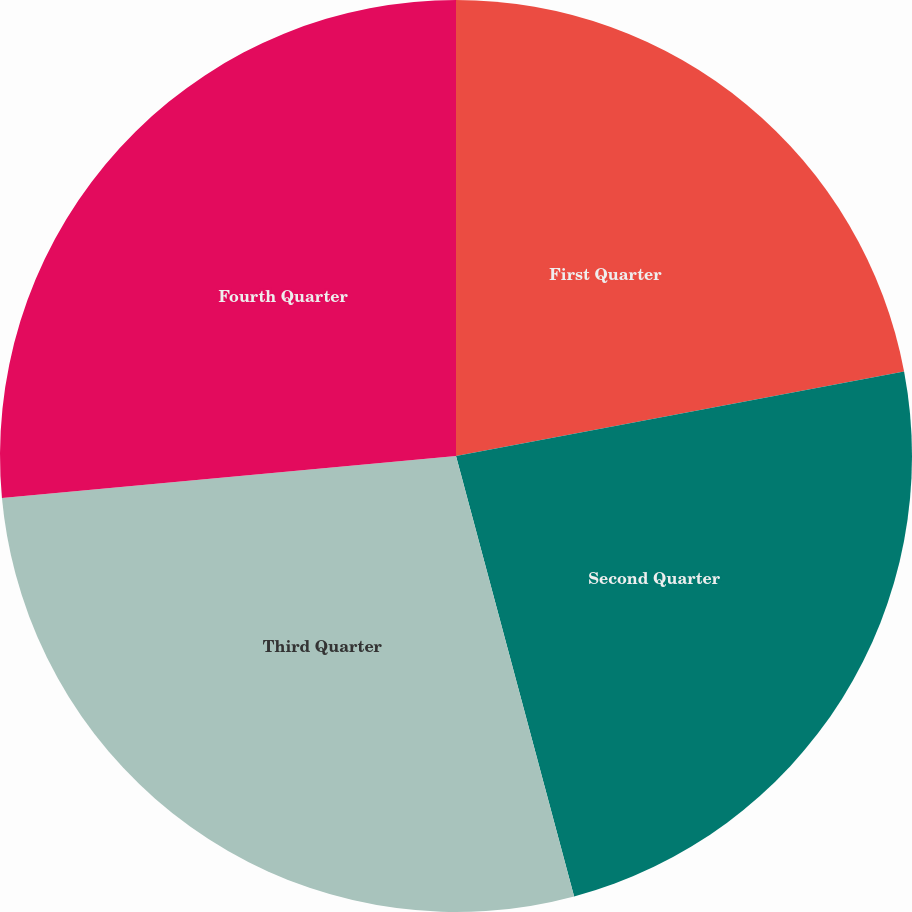<chart> <loc_0><loc_0><loc_500><loc_500><pie_chart><fcel>First Quarter<fcel>Second Quarter<fcel>Third Quarter<fcel>Fourth Quarter<nl><fcel>22.03%<fcel>23.8%<fcel>27.7%<fcel>26.47%<nl></chart> 